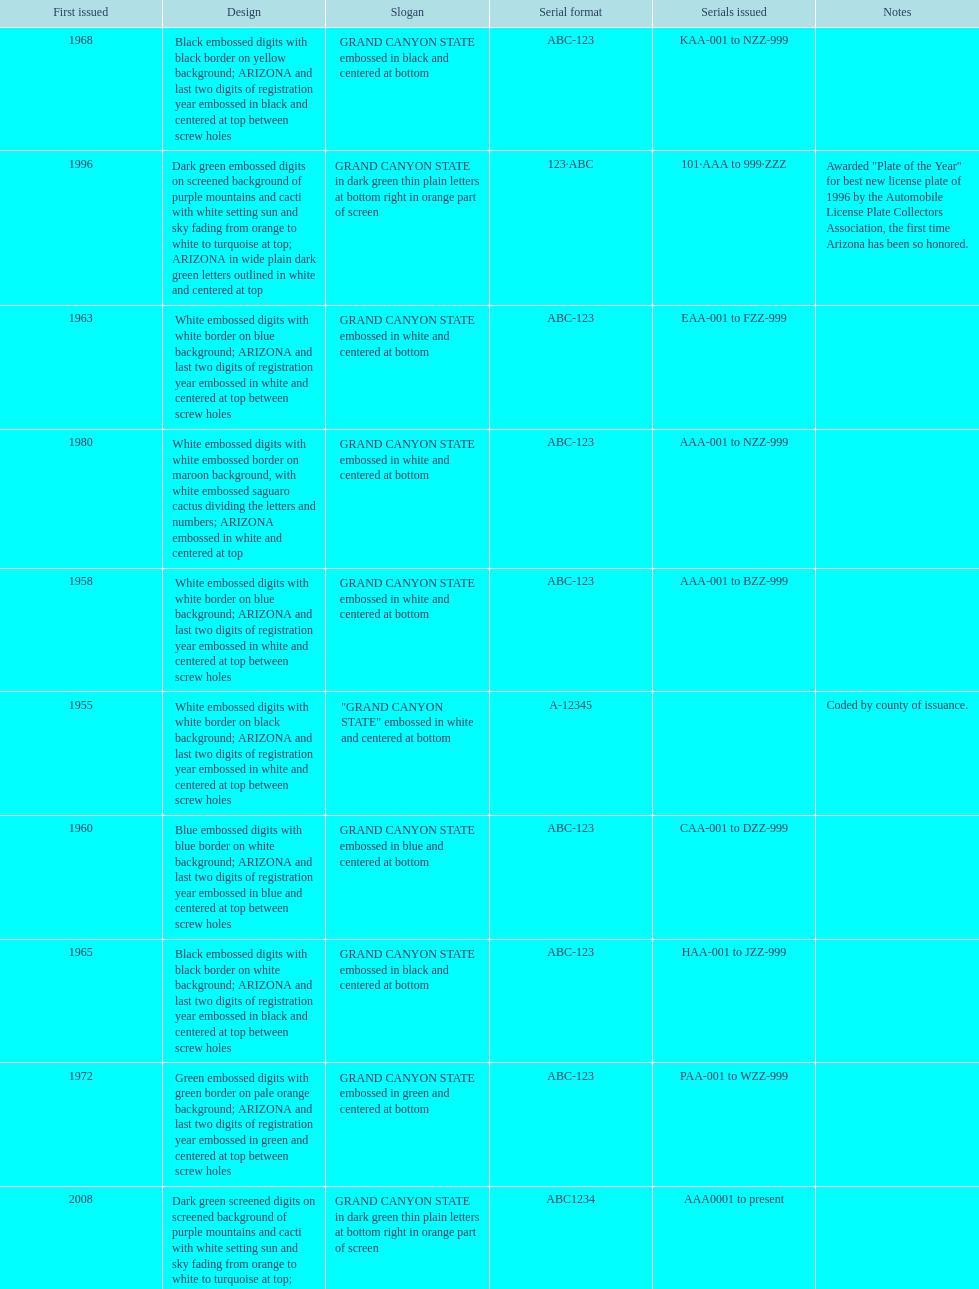Name the year of the license plate that has the largest amount of alphanumeric digits. 2008. 